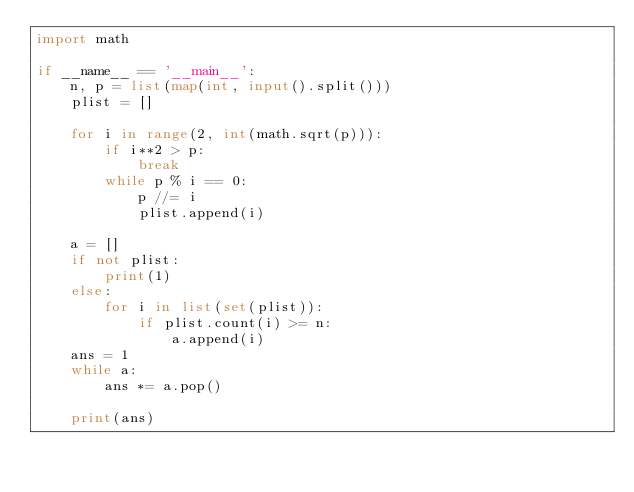Convert code to text. <code><loc_0><loc_0><loc_500><loc_500><_Python_>import math

if __name__ == '__main__':
    n, p = list(map(int, input().split()))
    plist = []

    for i in range(2, int(math.sqrt(p))):
        if i**2 > p:
            break
        while p % i == 0:
            p //= i
            plist.append(i)

    a = []
    if not plist:
        print(1)
    else:
        for i in list(set(plist)):
            if plist.count(i) >= n:
                a.append(i)
    ans = 1
    while a:
        ans *= a.pop()

    print(ans)
</code> 